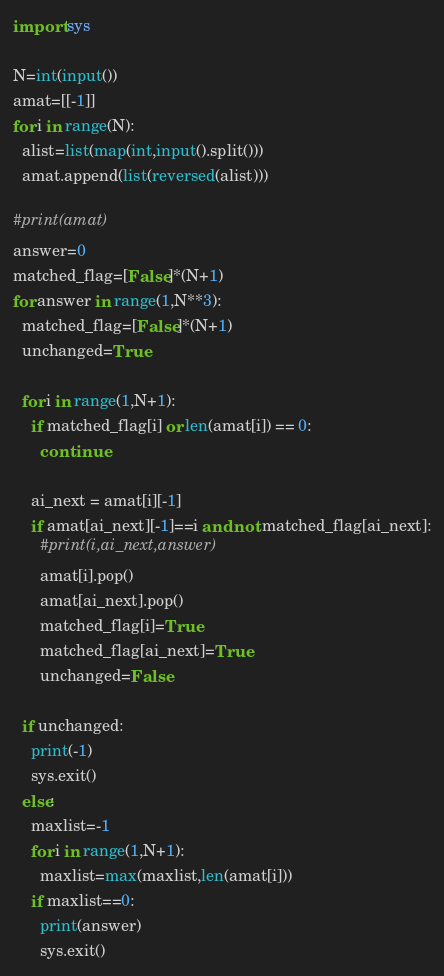Convert code to text. <code><loc_0><loc_0><loc_500><loc_500><_Python_>import sys

N=int(input())
amat=[[-1]]
for i in range(N):
  alist=list(map(int,input().split()))
  amat.append(list(reversed(alist)))
  
#print(amat)
answer=0
matched_flag=[False]*(N+1)
for answer in range(1,N**3): 
  matched_flag=[False]*(N+1)
  unchanged=True
  
  for i in range(1,N+1):
    if matched_flag[i] or len(amat[i]) == 0:
      continue
      
    ai_next = amat[i][-1]
    if amat[ai_next][-1]==i and not matched_flag[ai_next]:
      #print(i,ai_next,answer)
      amat[i].pop()
      amat[ai_next].pop()
      matched_flag[i]=True
      matched_flag[ai_next]=True
      unchanged=False
  
  if unchanged:
    print(-1)
    sys.exit()
  else:
    maxlist=-1
    for i in range(1,N+1):
      maxlist=max(maxlist,len(amat[i]))
    if maxlist==0:
      print(answer)
      sys.exit()
</code> 